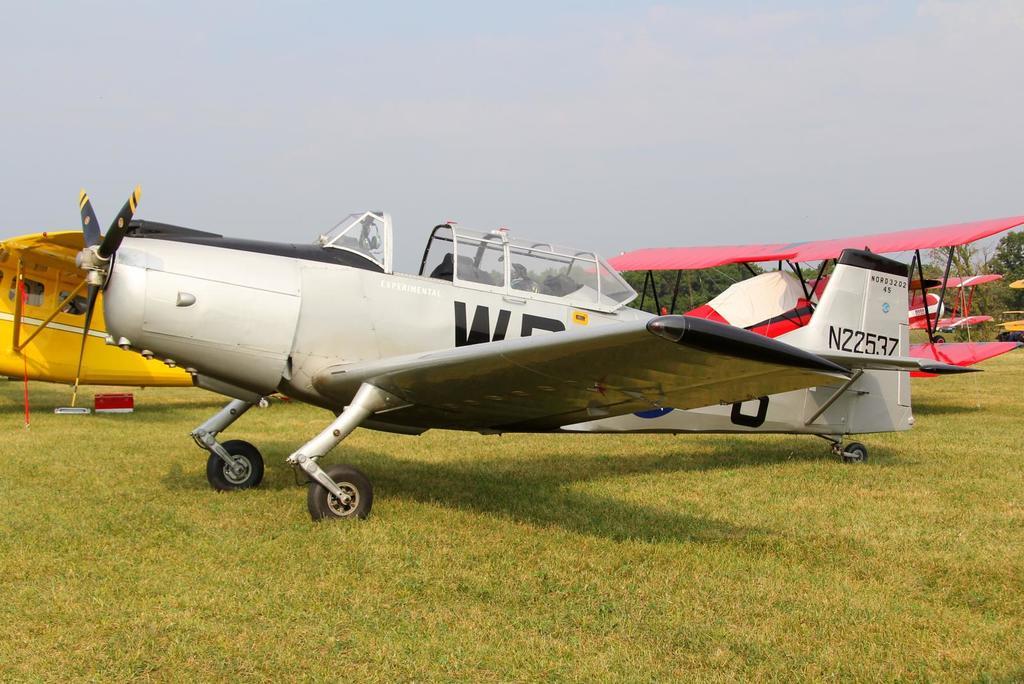What number is the klich jersey?
Provide a short and direct response. Unanswerable. 